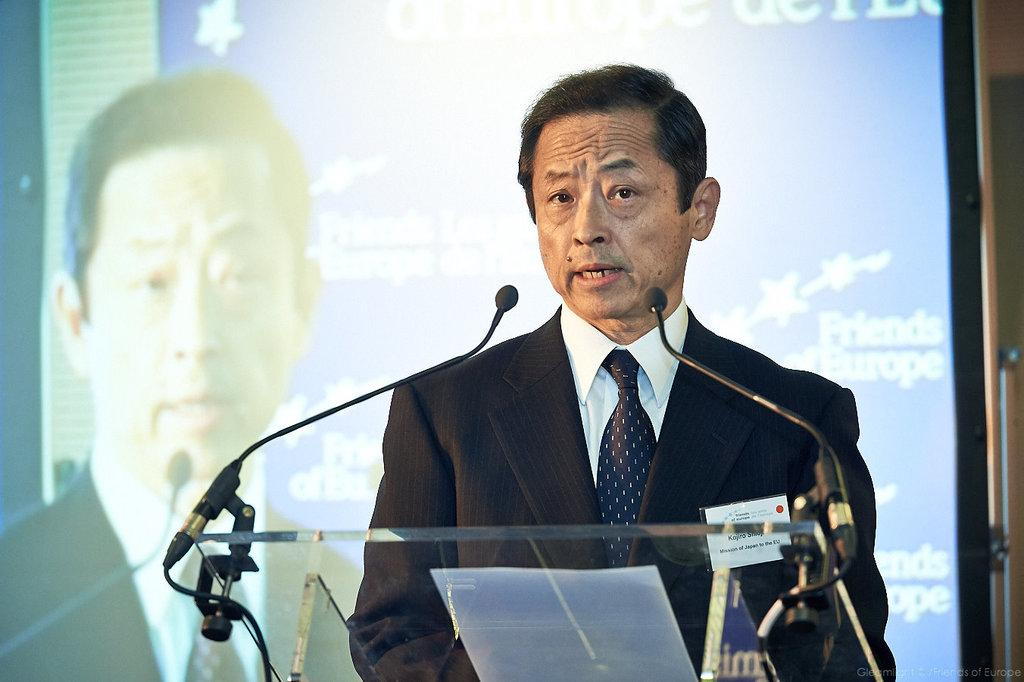Who is present in the image? There is a man in the image. What is the man wearing? The man is wearing a suit. What is in front of the man? There are mice fixed to a podium in front of the man. What can be seen in the background of the image? There is a screen visible in the background of the image. What type of soup is being served to the donkey in the image? There is no donkey or soup present in the image. 